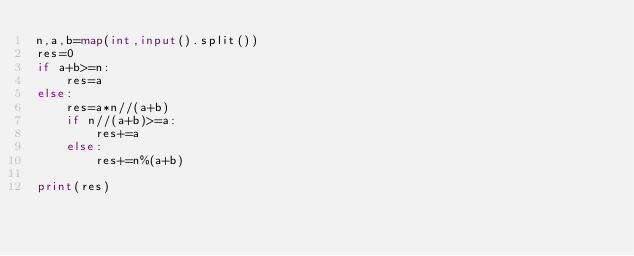Convert code to text. <code><loc_0><loc_0><loc_500><loc_500><_Python_>n,a,b=map(int,input().split())
res=0
if a+b>=n:
    res=a
else:
    res=a*n//(a+b)
    if n//(a+b)>=a:
        res+=a
    else:
        res+=n%(a+b)
        
print(res)</code> 